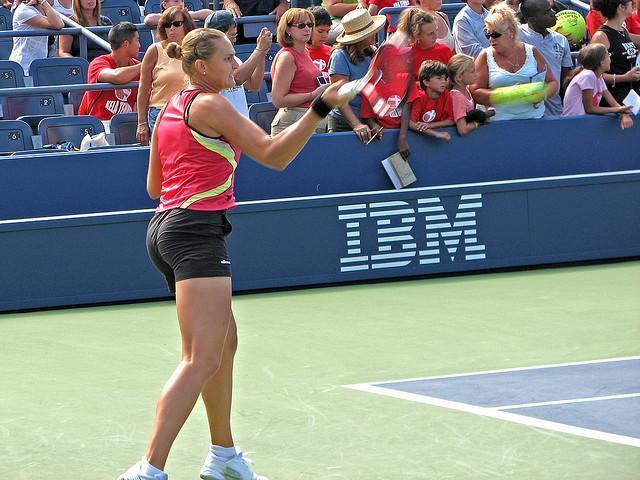How many people are in the picture?
Give a very brief answer. 11. How many grey cars are there in the image?
Give a very brief answer. 0. 